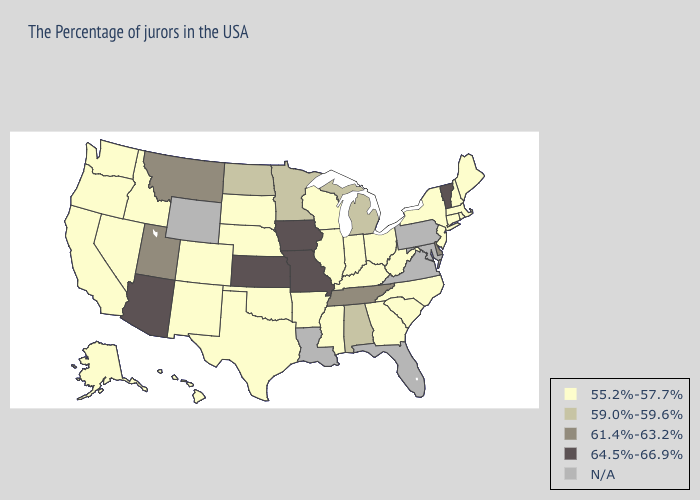Does Delaware have the lowest value in the South?
Short answer required. No. Among the states that border Massachusetts , which have the highest value?
Write a very short answer. Vermont. What is the highest value in the South ?
Give a very brief answer. 61.4%-63.2%. What is the highest value in the West ?
Keep it brief. 64.5%-66.9%. Name the states that have a value in the range N/A?
Short answer required. Maryland, Pennsylvania, Virginia, Florida, Louisiana, Wyoming. Among the states that border California , does Oregon have the lowest value?
Be succinct. Yes. Among the states that border Virginia , which have the highest value?
Short answer required. Tennessee. What is the highest value in the Northeast ?
Write a very short answer. 64.5%-66.9%. Among the states that border Utah , does Idaho have the lowest value?
Be succinct. Yes. Which states have the highest value in the USA?
Short answer required. Vermont, Missouri, Iowa, Kansas, Arizona. Name the states that have a value in the range 59.0%-59.6%?
Short answer required. Michigan, Alabama, Minnesota, North Dakota. What is the value of Hawaii?
Quick response, please. 55.2%-57.7%. What is the value of Tennessee?
Quick response, please. 61.4%-63.2%. Name the states that have a value in the range N/A?
Be succinct. Maryland, Pennsylvania, Virginia, Florida, Louisiana, Wyoming. 